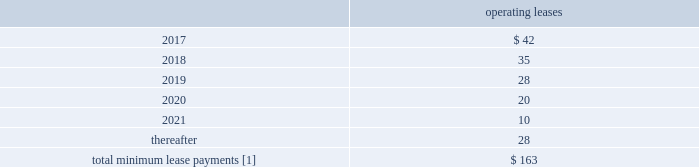F-80 www.thehartford.com the hartford financial services group , inc .
Notes to consolidated financial statements ( continued ) 14 .
Commitments and contingencies ( continued ) future minimum lease commitments as of december 31 , 2016 operating leases .
[1] excludes expected future minimum sublease income of approximately $ 2 , $ 2 , $ 2 , $ 2 , $ 0 and $ 0 in 2017 , 2018 , 2019 , 2020 , 2021 and thereafter respectively .
The company 2019s lease commitments consist primarily of lease agreements for office space , automobiles , and office equipment that expire at various dates .
Unfunded commitments as of december 31 , 2016 , the company has outstanding commitments totaling $ 1.6 billion , of which $ 1.2 billion is committed to fund limited partnership and other alternative investments , which may be called by the partnership during the commitment period to fund the purchase of new investments and partnership expenses .
Additionally , $ 313 of the outstanding commitments relate to various funding obligations associated with private placement securities .
The remaining outstanding commitments of $ 95 relate to mortgage loans the company is expecting to fund in the first half of 2017 .
Guaranty funds and other insurance-related assessments in all states , insurers licensed to transact certain classes of insurance are required to become members of a guaranty fund .
In most states , in the event of the insolvency of an insurer writing any such class of insurance in the state , the guaranty funds may assess its members to pay covered claims of the insolvent insurers .
Assessments are based on each member 2019s proportionate share of written premiums in the state for the classes of insurance in which the insolvent insurer was engaged .
Assessments are generally limited for any year to one or two percent of the premiums written per year depending on the state .
Some states permit member insurers to recover assessments paid through surcharges on policyholders or through full or partial premium tax offsets , while other states permit recovery of assessments through the rate filing process .
Liabilities for guaranty fund and other insurance-related assessments are accrued when an assessment is probable , when it can be reasonably estimated , and when the event obligating the company to pay an imposed or probable assessment has occurred .
Liabilities for guaranty funds and other insurance- related assessments are not discounted and are included as part of other liabilities in the consolidated balance sheets .
As of december 31 , 2016 and 2015 the liability balance was $ 134 and $ 138 , respectively .
As of december 31 , 2016 and 2015 amounts related to premium tax offsets of $ 34 and $ 44 , respectively , were included in other assets .
Derivative commitments certain of the company 2019s derivative agreements contain provisions that are tied to the financial strength ratings , as set by nationally recognized statistical agencies , of the individual legal entity that entered into the derivative agreement .
If the legal entity 2019s financial strength were to fall below certain ratings , the counterparties to the derivative agreements could demand immediate and ongoing full collateralization and in certain instances enable the counterparties to terminate the agreements and demand immediate settlement of all outstanding derivative positions traded under each impacted bilateral agreement .
The settlement amount is determined by netting the derivative positions transacted under each agreement .
If the termination rights were to be exercised by the counterparties , it could impact the legal entity 2019s ability to conduct hedging activities by increasing the associated costs and decreasing the willingness of counterparties to transact with the legal entity .
The aggregate fair value of all derivative instruments with credit-risk-related contingent features that are in a net liability position as of december 31 , 2016 was $ 1.4 billion .
Of this $ 1.4 billion , the legal entities have posted collateral of $ 1.7 billion in the normal course of business .
In addition , the company has posted collateral of $ 31 associated with a customized gmwb derivative .
Based on derivative market values as of december 31 , 2016 , a downgrade of one level below the current financial strength ratings by either moody 2019s or s&p would not require additional assets to be posted as collateral .
Based on derivative market values as of december 31 , 2016 , a downgrade of two levels below the current financial strength ratings by either moody 2019s or s&p would require additional $ 10 of assets to be posted as collateral .
These collateral amounts could change as derivative market values change , as a result of changes in our hedging activities or to the extent changes in contractual terms are negotiated .
The nature of the collateral that we post , when required , is primarily in the form of u.s .
Treasury bills , u.s .
Treasury notes and government agency securities .
Guarantees in the ordinary course of selling businesses or entities to third parties , the company has agreed to indemnify purchasers for losses arising subsequent to the closing due to breaches of representations and warranties with respect to the business or entity being sold or with respect to covenants and obligations of the company and/or its subsidiaries .
These obligations are typically subject to various time limitations , defined by the contract or by operation of law , such as statutes of limitation .
In some cases , the maximum potential obligation is subject to contractual limitations , while in other cases such limitations are not specified or applicable .
The company does not expect to make any payments on these guarantees and is not carrying any liabilities associated with these guarantees. .
What is the net operating lease obligation for 2017? 
Computations: (42 - 2)
Answer: 40.0. 